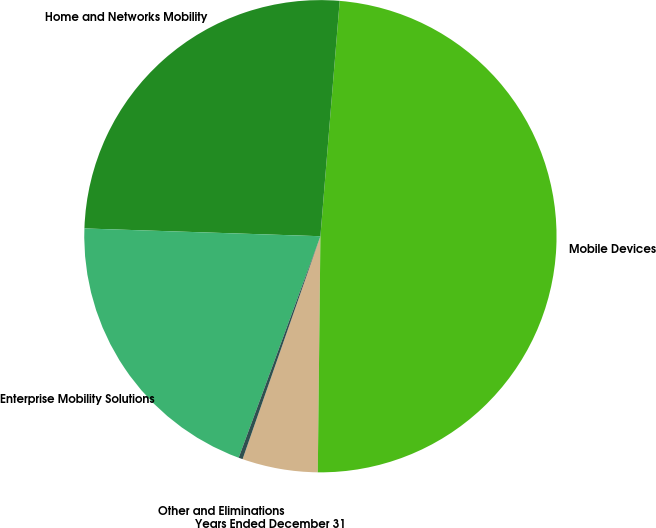<chart> <loc_0><loc_0><loc_500><loc_500><pie_chart><fcel>Years Ended December 31<fcel>Mobile Devices<fcel>Home and Networks Mobility<fcel>Enterprise Mobility Solutions<fcel>Other and Eliminations<nl><fcel>5.17%<fcel>48.88%<fcel>25.78%<fcel>19.9%<fcel>0.28%<nl></chart> 